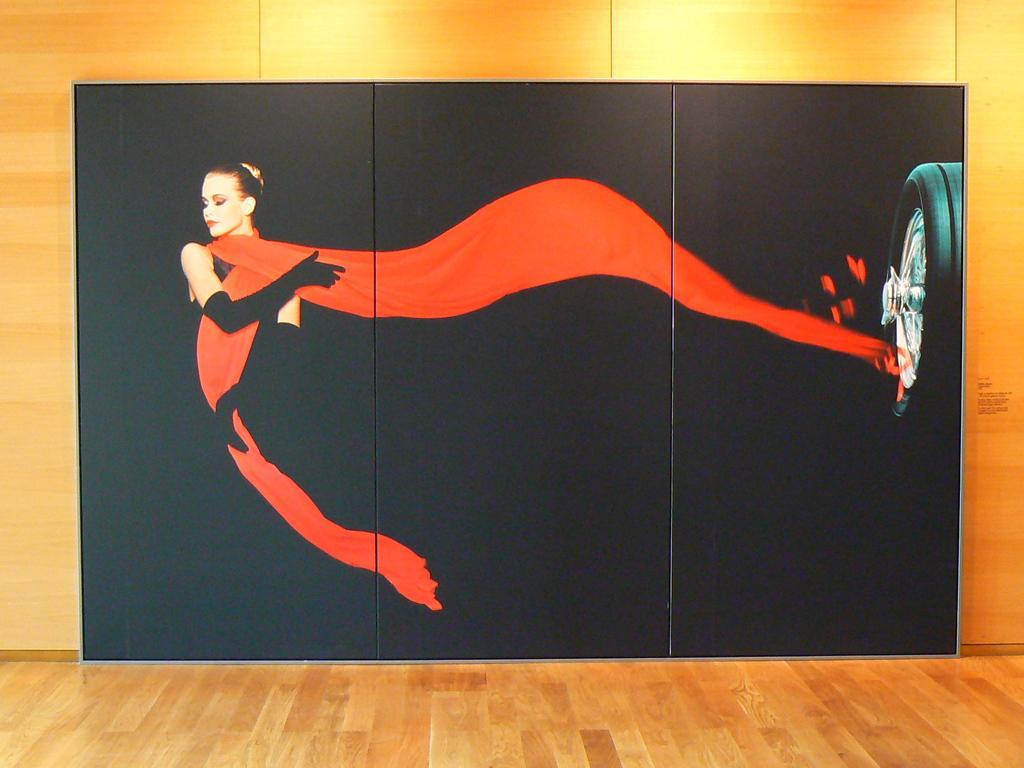Describe this image in one or two sentences. In this image there is a painting of a woman and a wheel of a vehicle on the wall. At the bottom of the image there is a floor. 